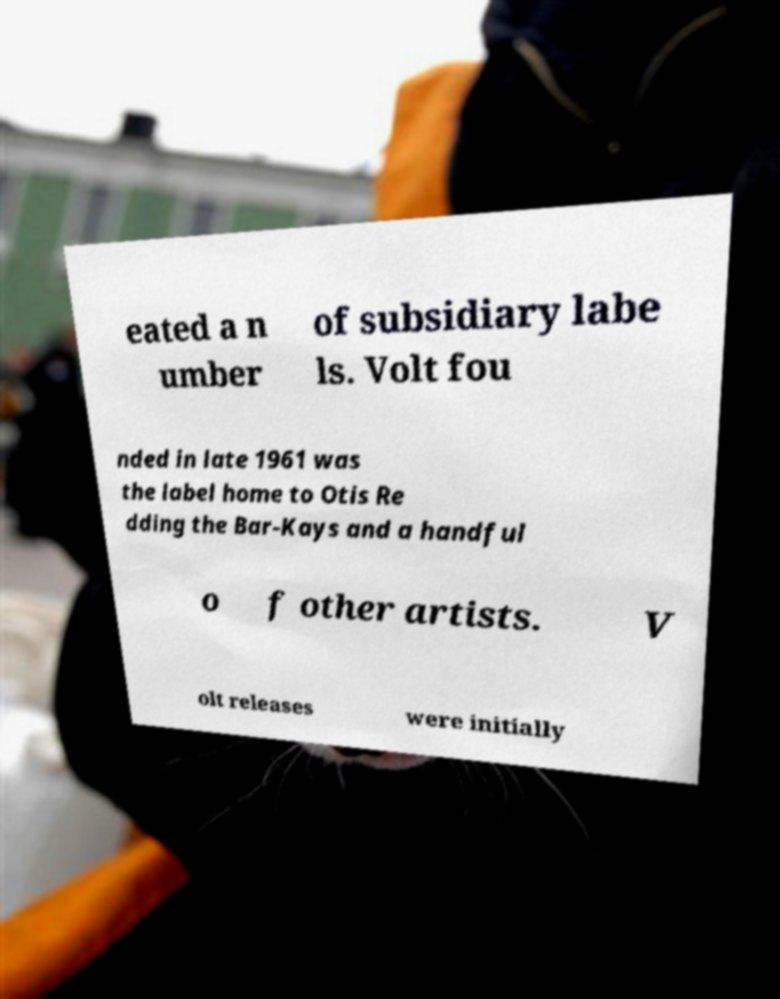Can you accurately transcribe the text from the provided image for me? eated a n umber of subsidiary labe ls. Volt fou nded in late 1961 was the label home to Otis Re dding the Bar-Kays and a handful o f other artists. V olt releases were initially 